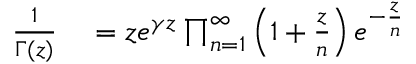<formula> <loc_0><loc_0><loc_500><loc_500>\begin{array} { r l } { { \frac { 1 } { \Gamma ( z ) } } } & = z e ^ { \gamma z } \prod _ { n = 1 } ^ { \infty } \left ( 1 + { \frac { z } { n } } \right ) e ^ { - { \frac { z } { n } } } } \end{array}</formula> 